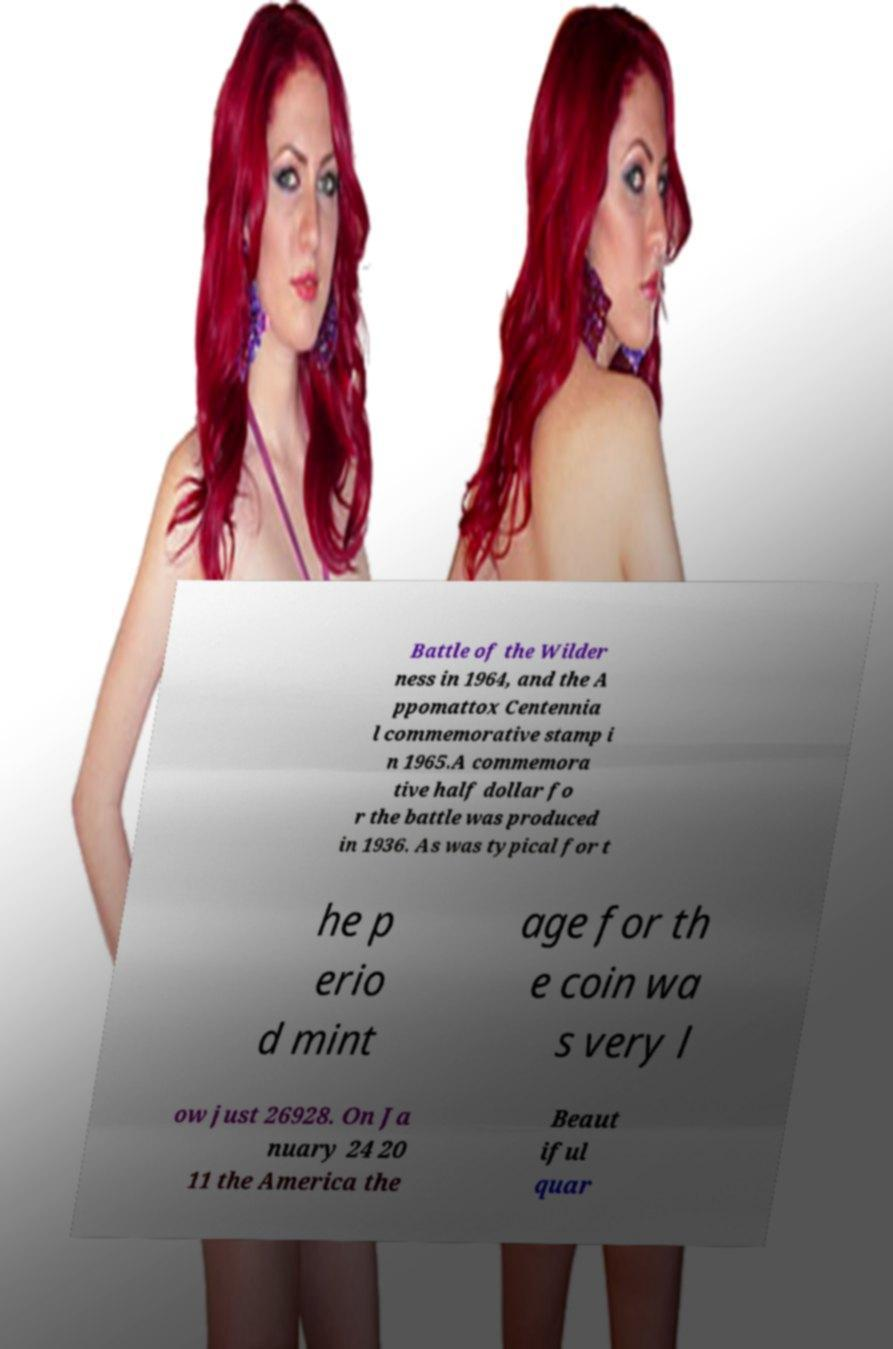Could you extract and type out the text from this image? Battle of the Wilder ness in 1964, and the A ppomattox Centennia l commemorative stamp i n 1965.A commemora tive half dollar fo r the battle was produced in 1936. As was typical for t he p erio d mint age for th e coin wa s very l ow just 26928. On Ja nuary 24 20 11 the America the Beaut iful quar 